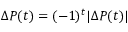Convert formula to latex. <formula><loc_0><loc_0><loc_500><loc_500>\Delta P ( t ) = ( - 1 ) ^ { t } | \Delta P ( t ) |</formula> 